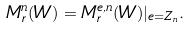<formula> <loc_0><loc_0><loc_500><loc_500>M ^ { n } _ { r } ( W ) = M ^ { e , n } _ { r } ( W ) | _ { e = Z _ { n } } .</formula> 